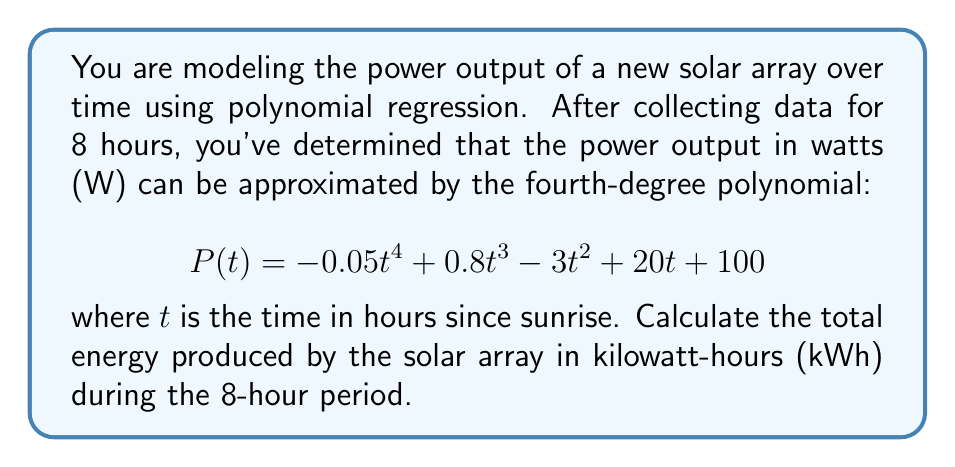What is the answer to this math problem? To solve this problem, we need to follow these steps:

1) The energy produced is equal to the integral of the power function over time. We need to integrate $P(t)$ from $t=0$ to $t=8$.

2) The integral of $P(t)$ is:

   $$\int P(t) dt = \int (-0.05t^4 + 0.8t^3 - 3t^2 + 20t + 100) dt$$

3) Integrating each term:

   $$\int P(t) dt = -0.01t^5 + 0.2t^4 - t^3 + 10t^2 + 100t + C$$

4) We need to evaluate this from $t=0$ to $t=8$. Let's call this integral $E(t)$:

   $$E(8) - E(0) = [-0.01(8^5) + 0.2(8^4) - 8^3 + 10(8^2) + 100(8)] - [-0.01(0^5) + 0.2(0^4) - 0^3 + 10(0^2) + 100(0)]$$

5) Simplify:

   $$E(8) - E(0) = [-25.6 + 819.2 - 512 + 640 + 800] - [0]$$
   
   $$E(8) - E(0) = 1721.6$$

6) This result is in watt-hours (Wh). To convert to kilowatt-hours (kWh), divide by 1000:

   $$1721.6 \div 1000 = 1.7216 \text{ kWh}$$
Answer: $1.7216 \text{ kWh}$ 